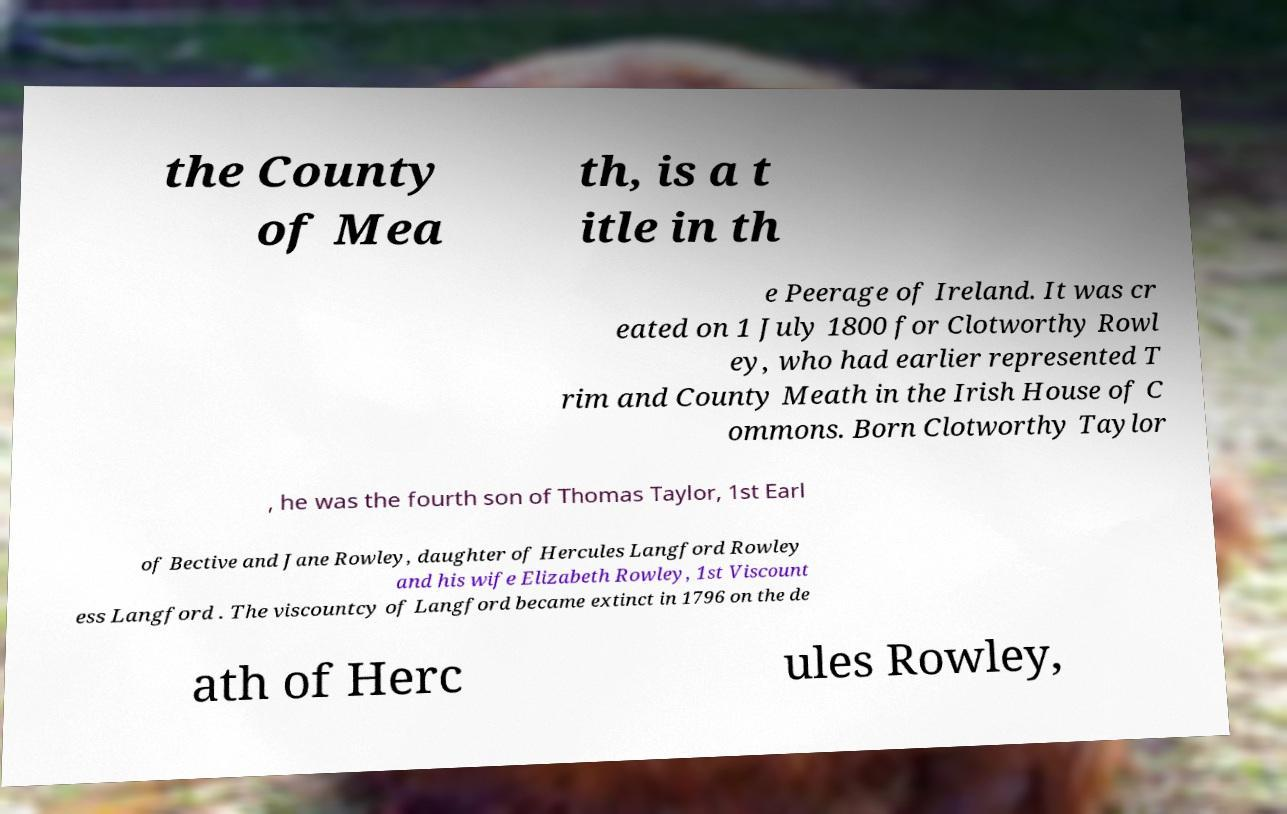Can you read and provide the text displayed in the image?This photo seems to have some interesting text. Can you extract and type it out for me? the County of Mea th, is a t itle in th e Peerage of Ireland. It was cr eated on 1 July 1800 for Clotworthy Rowl ey, who had earlier represented T rim and County Meath in the Irish House of C ommons. Born Clotworthy Taylor , he was the fourth son of Thomas Taylor, 1st Earl of Bective and Jane Rowley, daughter of Hercules Langford Rowley and his wife Elizabeth Rowley, 1st Viscount ess Langford . The viscountcy of Langford became extinct in 1796 on the de ath of Herc ules Rowley, 